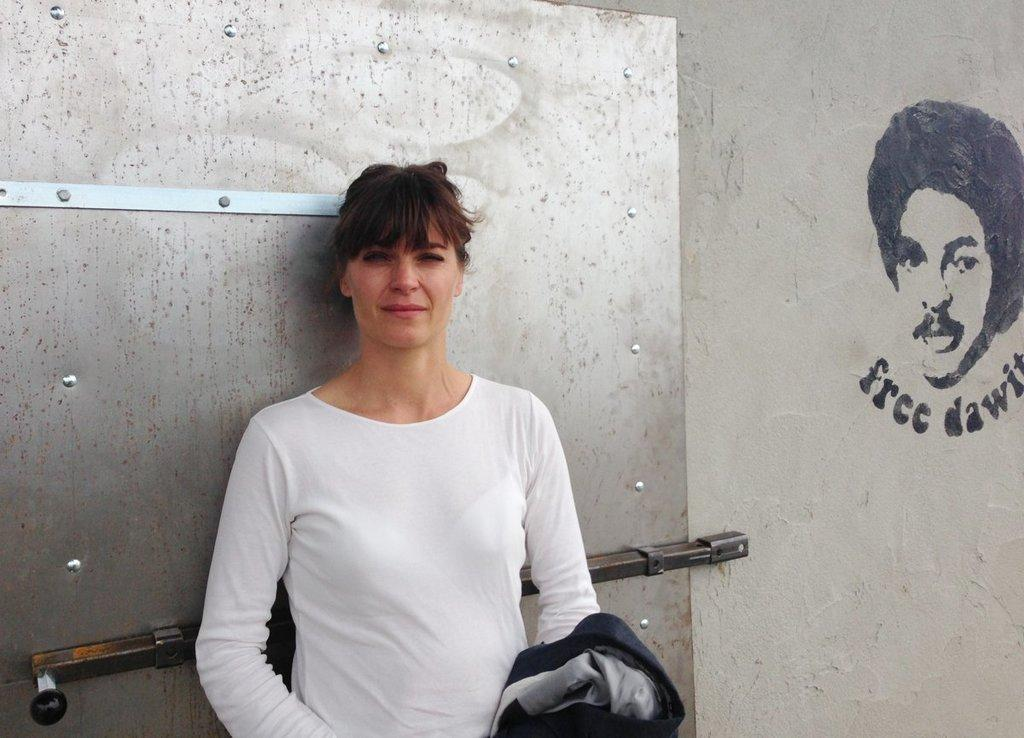What can be seen in the background of the image? There is a person's face paint in the background of the image. Can you describe the woman in the image? The woman is standing in the image and is wearing a white t-shirt. What is the woman standing next to in the image? There is a stand in the image. Can you tell me how many toads are sitting on the stand in the image? There are no toads present in the image; it features a woman standing next to a stand with face paint in the background. 